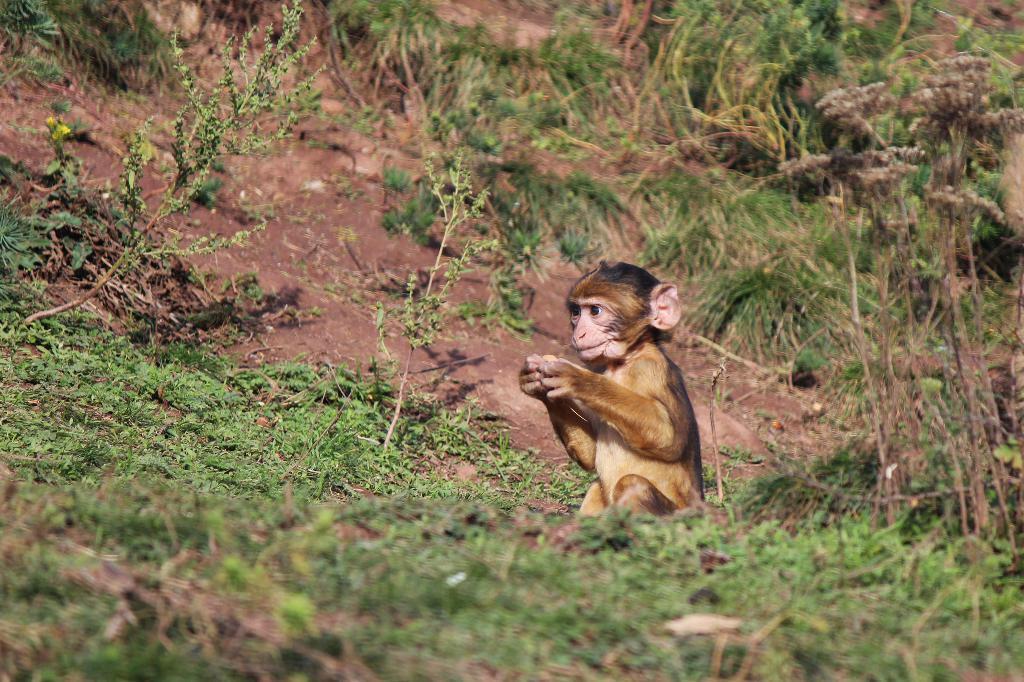In one or two sentences, can you explain what this image depicts? In the center of the image there is a monkey. In the background we can see plants and grass. 